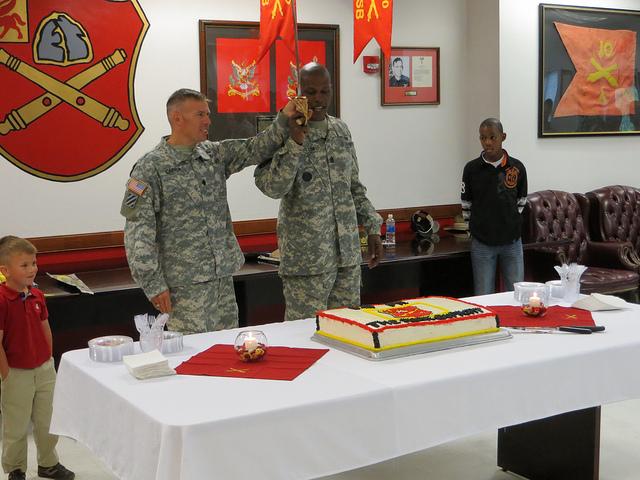How many children are in this photo?
Give a very brief answer. 2. How many cakes are there?
Quick response, please. 1. Who do they work for?
Answer briefly. Military. 